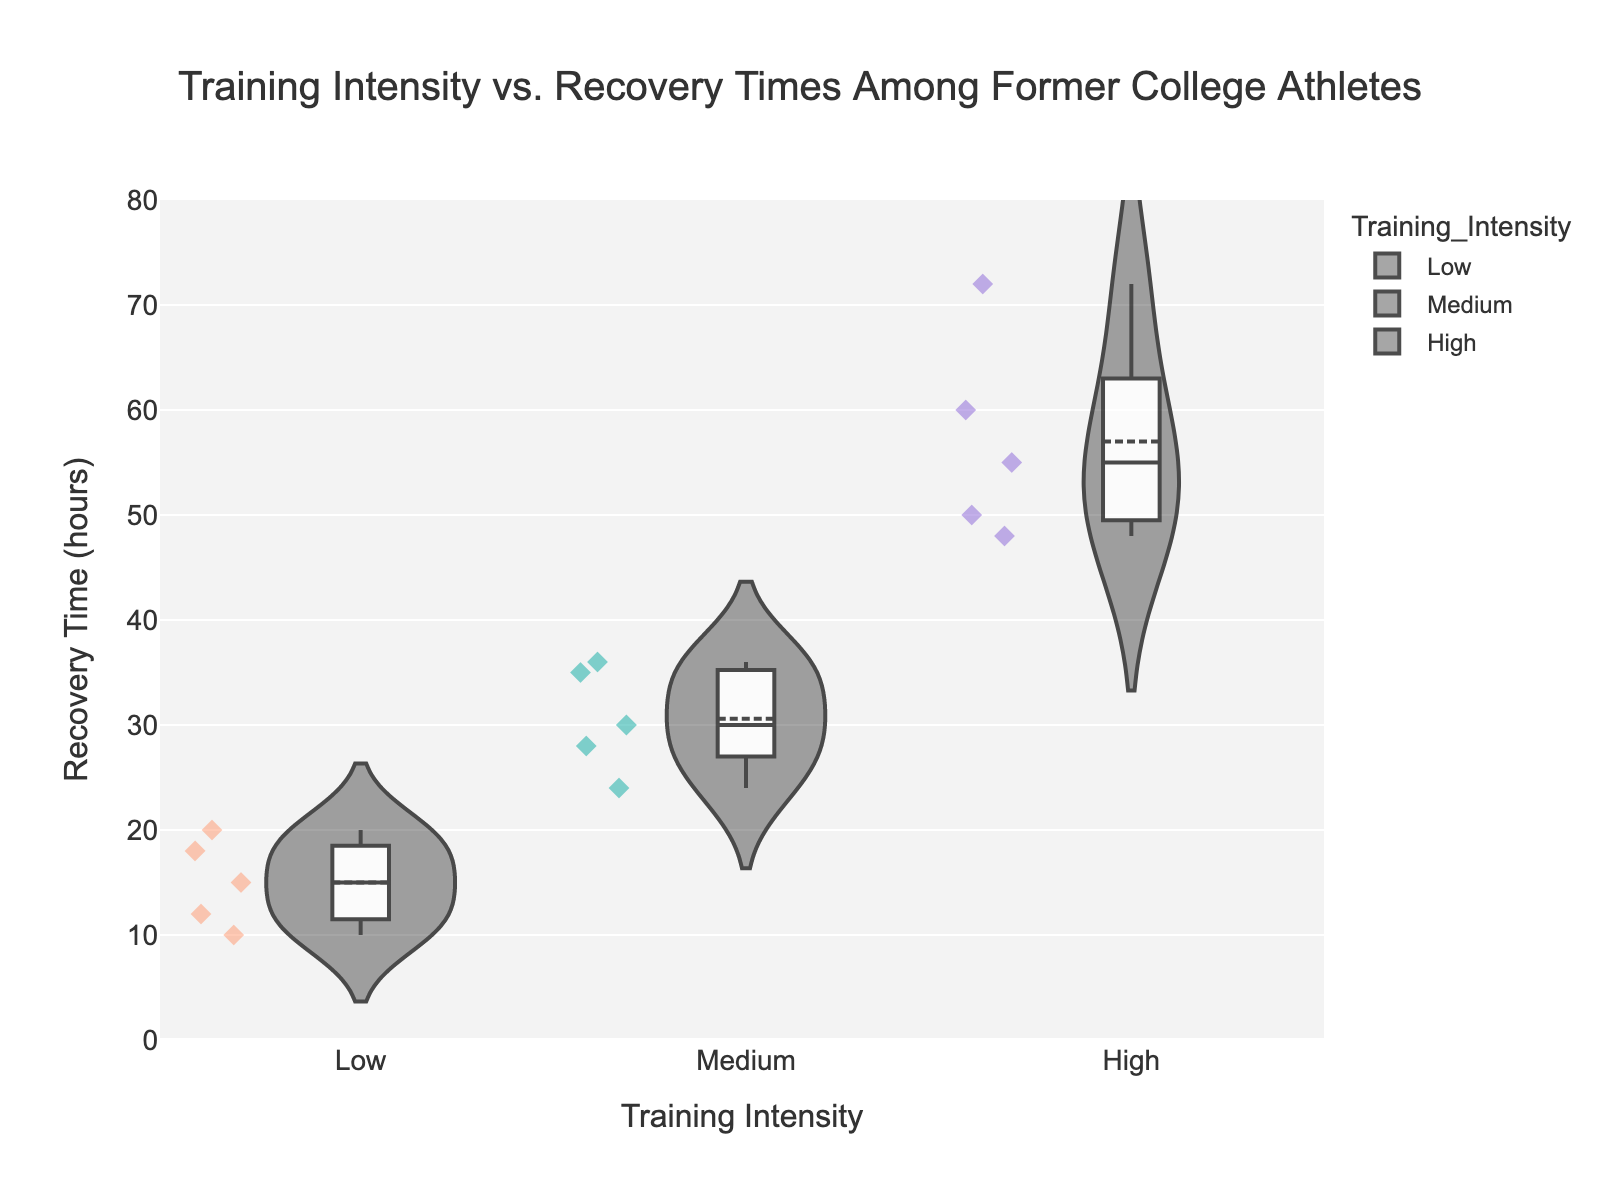What is the title of the chart? The title is usually prominently displayed at the top of the figure. In this case, it is "Training Intensity vs. Recovery Times Among Former College Athletes."
Answer: "Training Intensity vs. Recovery Times Among Former College Athletes" What is the color used for the 'Medium' training intensity? The color of each training intensity category is distinct. The color for 'Medium' training intensity is light sea green.
Answer: Light sea green How many data points are there for 'Low' training intensity? Count the number of data points shown within the 'Low' violin, each represented by a diamond symbol. There are six.
Answer: 6 What is the median recovery time for 'High' training intensity? Look for the median line within the 'High' training intensity violin plot. It is around 55 hours.
Answer: 55 hours Which training intensity category has the widest range of recovery times? The range is determined by the spread of the points in each violin. 'High' training intensity has data points ranging from 48 to 72 hours, the widest range.
Answer: High What is the difference between the highest and lowest recovery times for 'Medium' training intensity? The highest recovery time for 'Medium' is 36 hours, and the lowest is 24 hours. The difference is 36 - 24 = 12 hours.
Answer: 12 hours Compare the average recovery times for 'Low' and 'High' training intensities. Which is greater and by how much? First, calculate the average recovery time for each intensity. For 'Low': (12 + 18 + 15 + 20 + 10) / 6 = 15 hours. For 'High': (48 + 72 + 60 + 50 + 55) / 5 = 57 hours. The difference is 57 - 15 = 42 hours, with 'High' being greater.
Answer: High by 42 hours How does the peak density of recovery times compare across different training intensities? View the width of the violin plot at different parts. The 'Low' and 'Medium' intensities have peak densities around the center, whereas 'High' is more spread out.
Answer: 'Low' and 'Medium' have more pronounced peaks in density around the center than 'High.' What would you say about the distribution of recovery times for 'Medium' training intensity? The 'Medium' violin plot shows that most data points are centered and closer together, with a slight spread towards the higher and lower ends but not as extreme as 'High' intensity.
Answer: Most recovery times are around the center with a slight spread What can you infer about training intensity and its impact on recovery times from the violin chart? The data indicates that higher training intensities generally correspond to longer and more variable recovery times, while lower intensities result in shorter and more consistent recovery periods.
Answer: Higher intensity, longer recovery. Lower intensity, shorter recovery 